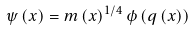Convert formula to latex. <formula><loc_0><loc_0><loc_500><loc_500>\psi \left ( x \right ) = m \left ( x \right ) ^ { 1 / 4 } \phi \left ( q \left ( x \right ) \right )</formula> 